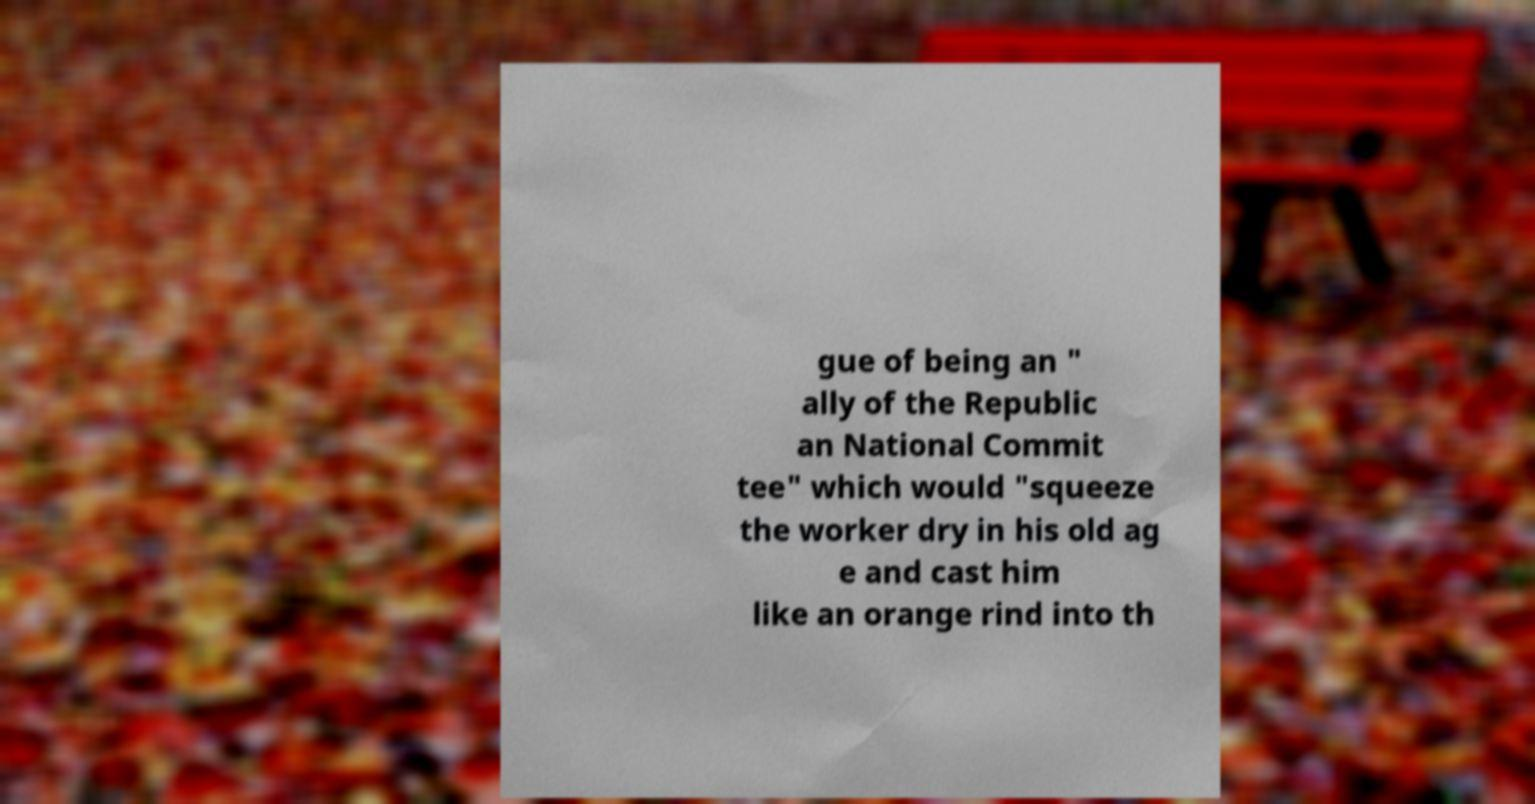Please identify and transcribe the text found in this image. gue of being an " ally of the Republic an National Commit tee" which would "squeeze the worker dry in his old ag e and cast him like an orange rind into th 